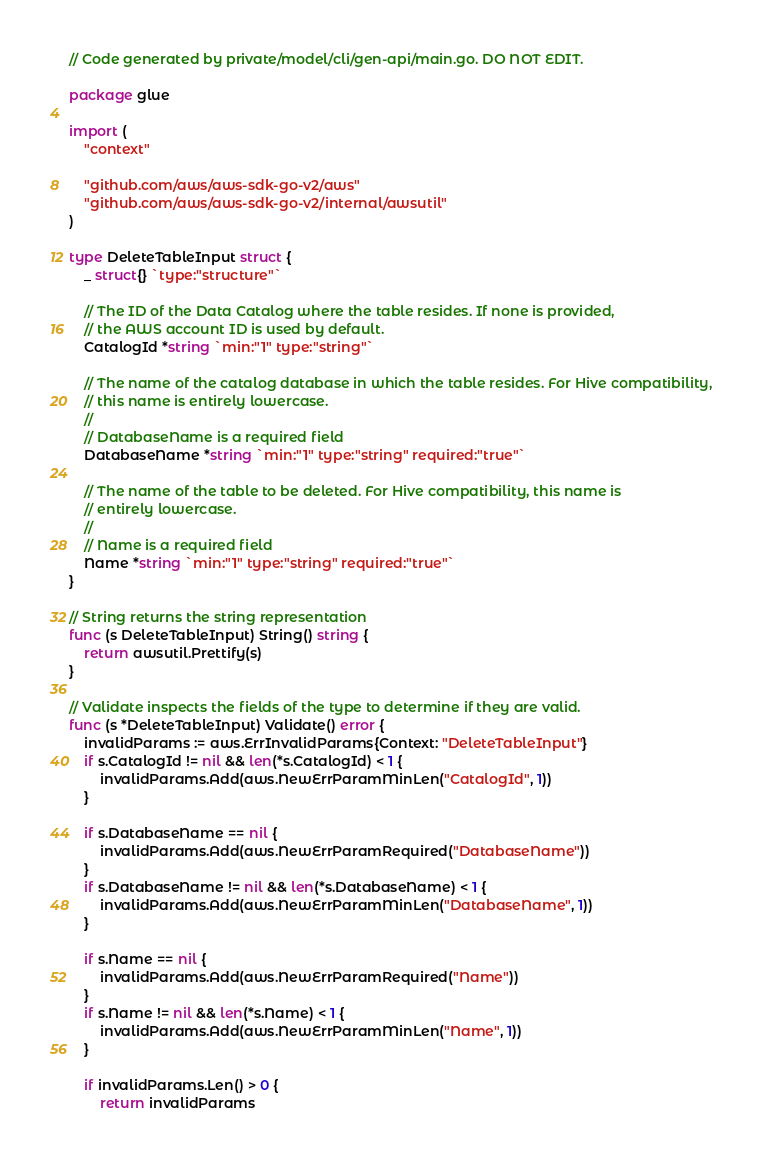<code> <loc_0><loc_0><loc_500><loc_500><_Go_>// Code generated by private/model/cli/gen-api/main.go. DO NOT EDIT.

package glue

import (
	"context"

	"github.com/aws/aws-sdk-go-v2/aws"
	"github.com/aws/aws-sdk-go-v2/internal/awsutil"
)

type DeleteTableInput struct {
	_ struct{} `type:"structure"`

	// The ID of the Data Catalog where the table resides. If none is provided,
	// the AWS account ID is used by default.
	CatalogId *string `min:"1" type:"string"`

	// The name of the catalog database in which the table resides. For Hive compatibility,
	// this name is entirely lowercase.
	//
	// DatabaseName is a required field
	DatabaseName *string `min:"1" type:"string" required:"true"`

	// The name of the table to be deleted. For Hive compatibility, this name is
	// entirely lowercase.
	//
	// Name is a required field
	Name *string `min:"1" type:"string" required:"true"`
}

// String returns the string representation
func (s DeleteTableInput) String() string {
	return awsutil.Prettify(s)
}

// Validate inspects the fields of the type to determine if they are valid.
func (s *DeleteTableInput) Validate() error {
	invalidParams := aws.ErrInvalidParams{Context: "DeleteTableInput"}
	if s.CatalogId != nil && len(*s.CatalogId) < 1 {
		invalidParams.Add(aws.NewErrParamMinLen("CatalogId", 1))
	}

	if s.DatabaseName == nil {
		invalidParams.Add(aws.NewErrParamRequired("DatabaseName"))
	}
	if s.DatabaseName != nil && len(*s.DatabaseName) < 1 {
		invalidParams.Add(aws.NewErrParamMinLen("DatabaseName", 1))
	}

	if s.Name == nil {
		invalidParams.Add(aws.NewErrParamRequired("Name"))
	}
	if s.Name != nil && len(*s.Name) < 1 {
		invalidParams.Add(aws.NewErrParamMinLen("Name", 1))
	}

	if invalidParams.Len() > 0 {
		return invalidParams</code> 